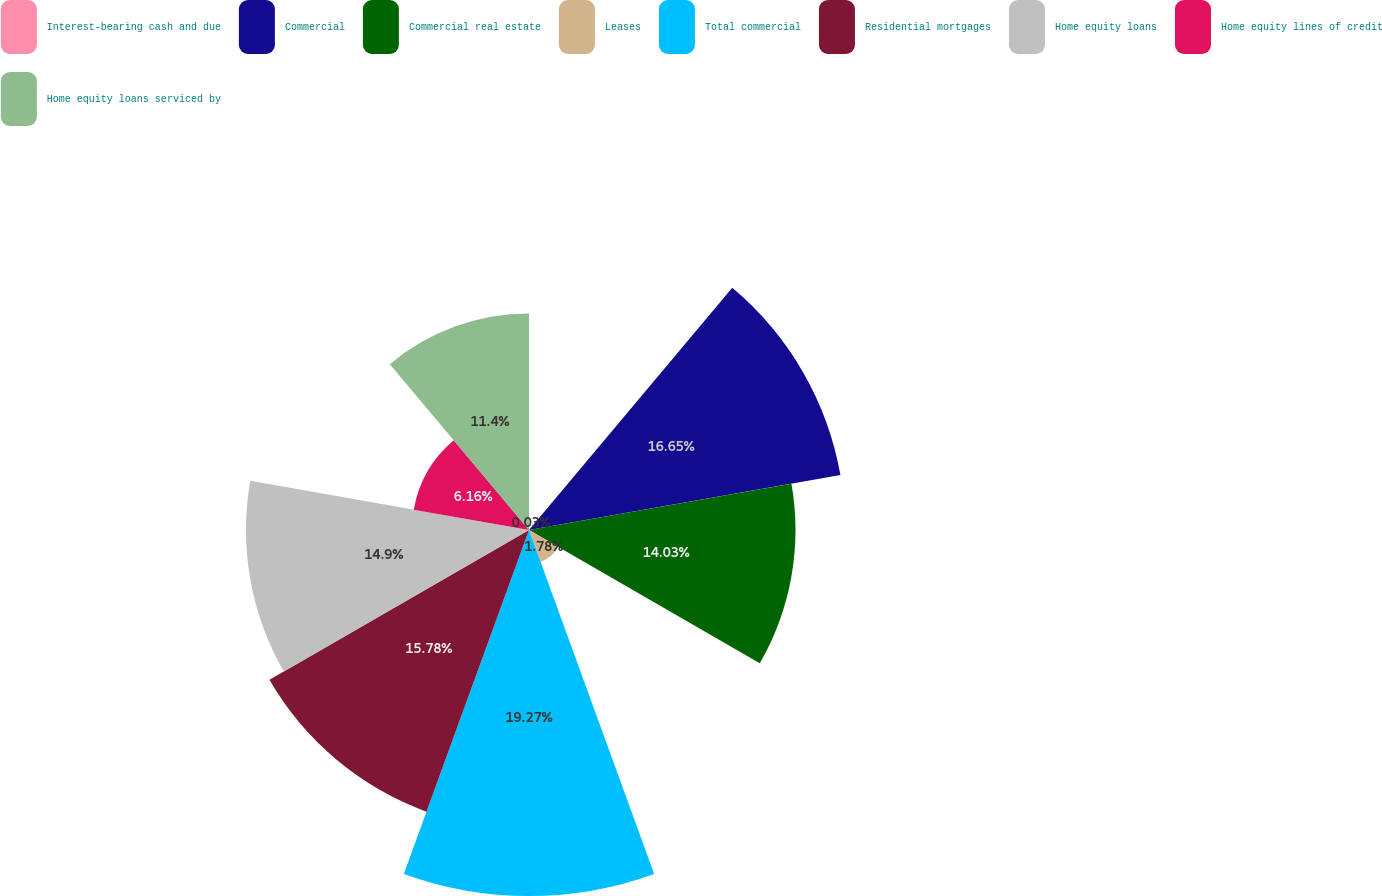Convert chart. <chart><loc_0><loc_0><loc_500><loc_500><pie_chart><fcel>Interest-bearing cash and due<fcel>Commercial<fcel>Commercial real estate<fcel>Leases<fcel>Total commercial<fcel>Residential mortgages<fcel>Home equity loans<fcel>Home equity lines of credit<fcel>Home equity loans serviced by<nl><fcel>0.03%<fcel>16.65%<fcel>14.03%<fcel>1.78%<fcel>19.27%<fcel>15.78%<fcel>14.9%<fcel>6.16%<fcel>11.4%<nl></chart> 